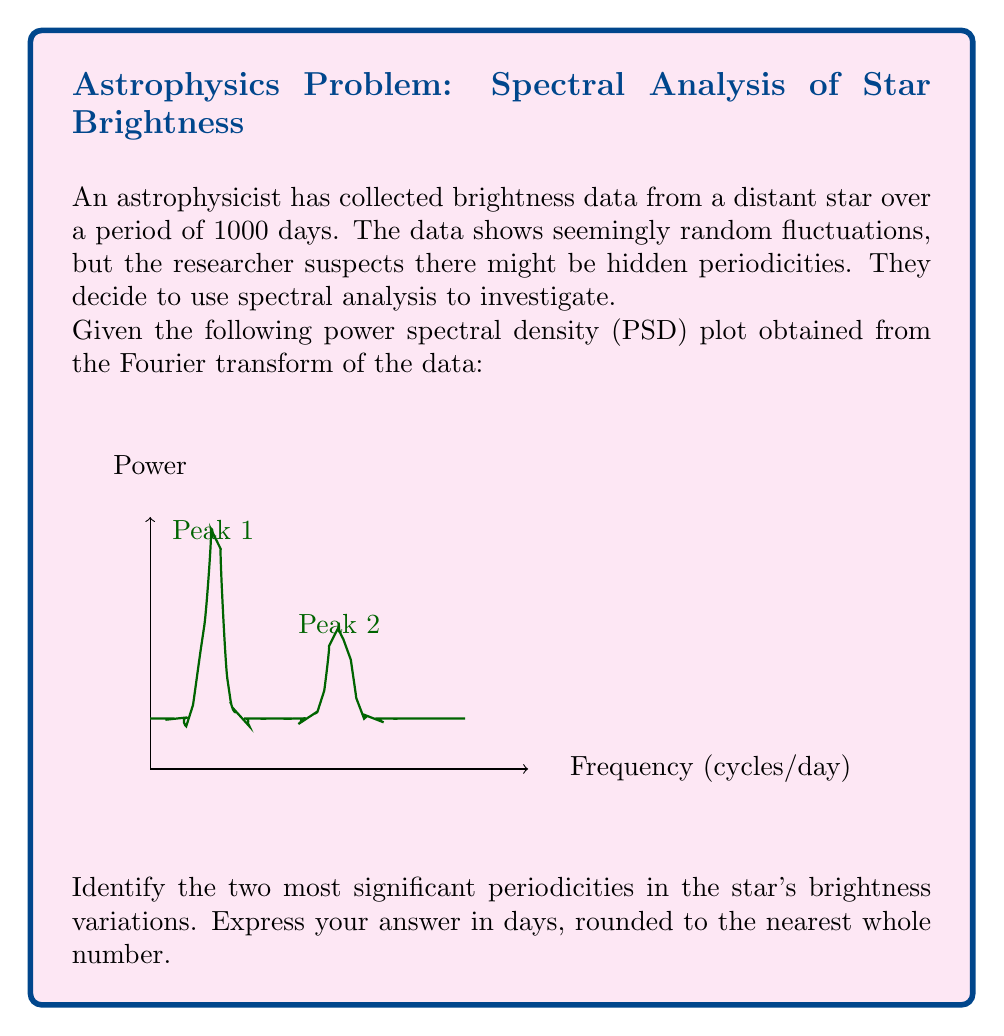Could you help me with this problem? To solve this problem, we need to follow these steps:

1) In spectral analysis, peaks in the power spectral density (PSD) plot indicate significant periodicities in the time series data.

2) From the given PSD plot, we can see two prominent peaks:
   Peak 1 at frequency $f_1 \approx 0.1$ cycles/day
   Peak 2 at frequency $f_2 \approx 0.3$ cycles/day

3) To convert frequency to period, we use the relationship:
   $$T = \frac{1}{f}$$
   where $T$ is the period in days and $f$ is the frequency in cycles/day.

4) For Peak 1:
   $$T_1 = \frac{1}{f_1} = \frac{1}{0.1} = 10 \text{ days}$$

5) For Peak 2:
   $$T_2 = \frac{1}{f_2} = \frac{1}{0.3} \approx 3.33 \text{ days}$$

6) Rounding to the nearest whole number:
   $T_1 = 10$ days
   $T_2 = 3$ days

Therefore, the two most significant periodicities in the star's brightness variations are approximately 10 days and 3 days.
Answer: 10 days and 3 days 